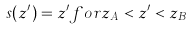Convert formula to latex. <formula><loc_0><loc_0><loc_500><loc_500>s ( z ^ { \prime } ) = z ^ { \prime } f o r z _ { A } < z ^ { \prime } < z _ { B }</formula> 